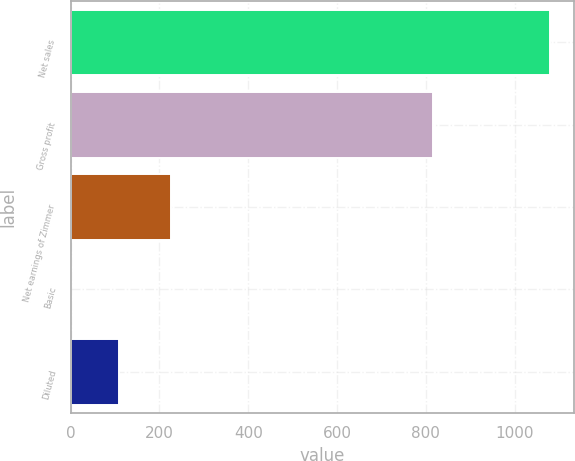Convert chart. <chart><loc_0><loc_0><loc_500><loc_500><bar_chart><fcel>Net sales<fcel>Gross profit<fcel>Net earnings of Zimmer<fcel>Basic<fcel>Diluted<nl><fcel>1079.5<fcel>817.2<fcel>227.1<fcel>0.99<fcel>108.84<nl></chart> 